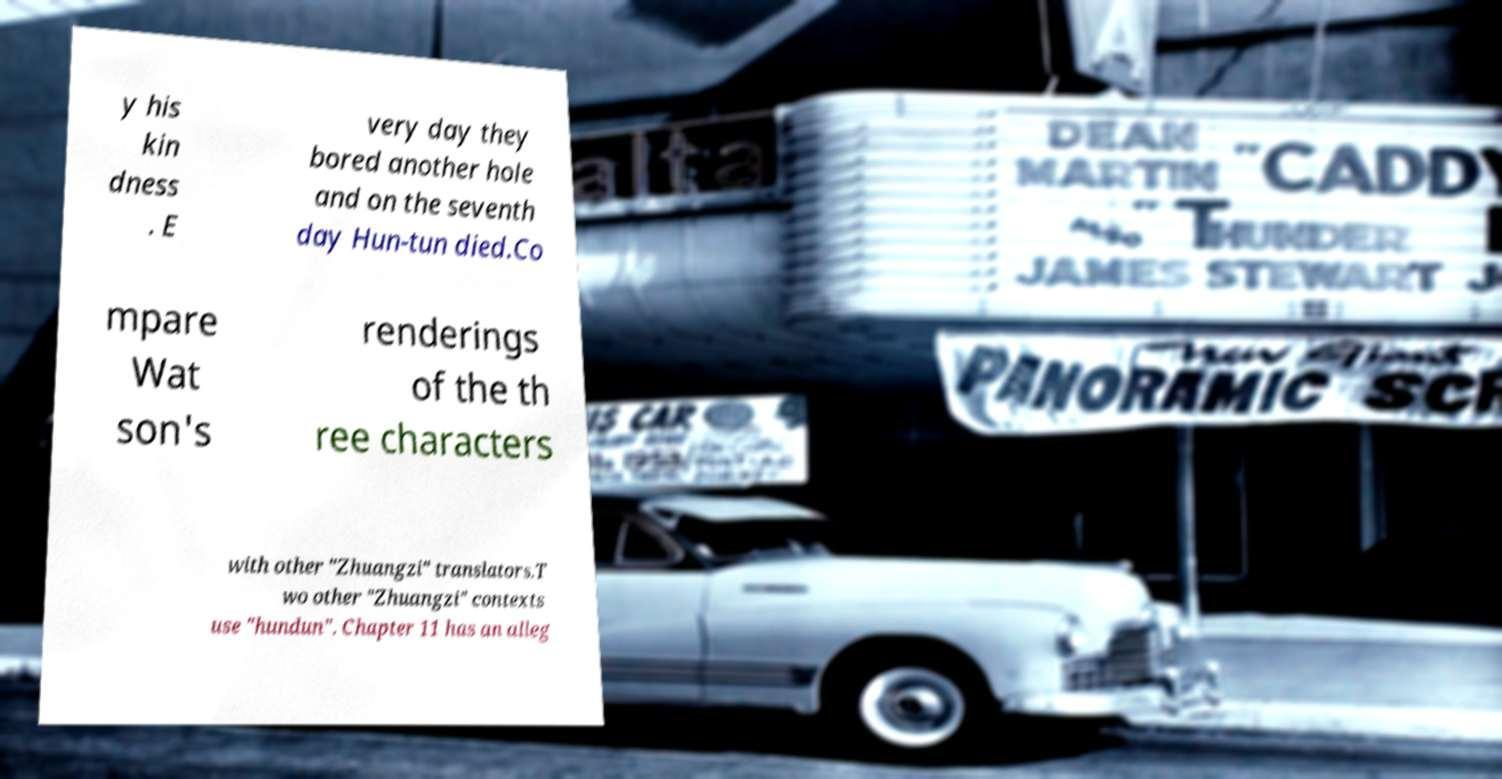For documentation purposes, I need the text within this image transcribed. Could you provide that? y his kin dness . E very day they bored another hole and on the seventh day Hun-tun died.Co mpare Wat son's renderings of the th ree characters with other "Zhuangzi" translators.T wo other "Zhuangzi" contexts use "hundun". Chapter 11 has an alleg 